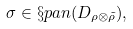<formula> <loc_0><loc_0><loc_500><loc_500>\sigma \in \S p a n ( D _ { \rho \otimes \tilde { \rho } } ) ,</formula> 